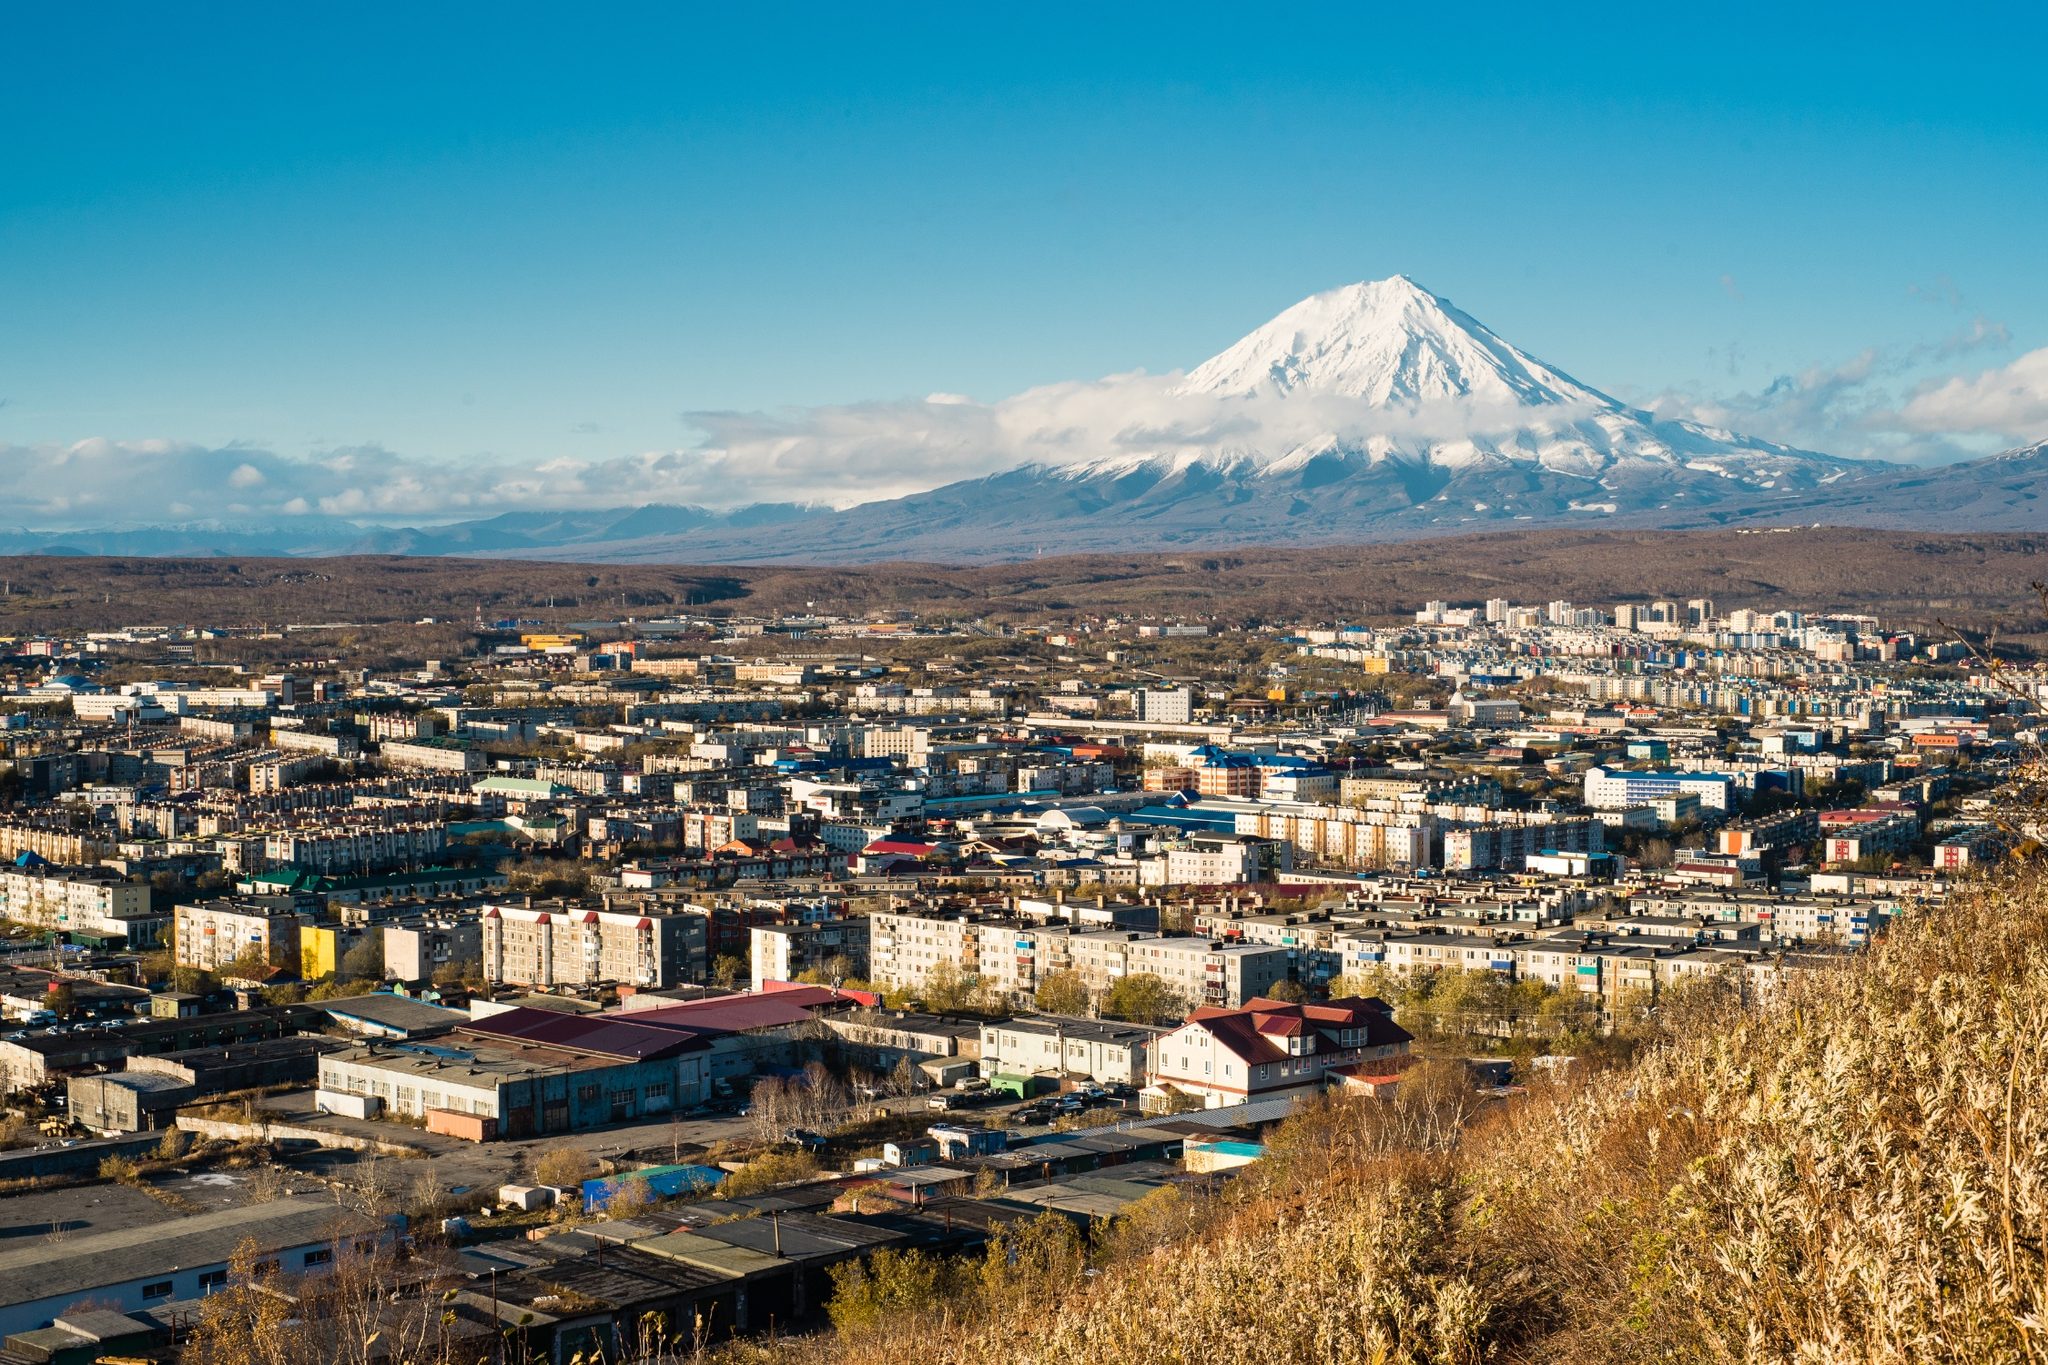What kind of businesses would thrive in this region and why? The businesses that would thrive in Petropavlovsk-Kamchatsky are those that leverage the unique natural and cultural attributes of the region. Tourism-related enterprises, including adventure tourism, eco-tourism, and cultural tours, could flourish by showcasing the breathtaking landscapes, volcanic features, and indigenous heritage. Sustainable technology firms focusing on geothermal energy would benefit from the region's volcanic activity, providing clean energy solutions locally and possibly internationally. Fisheries and seafood processing businesses could capitalize on the abundant marine resources in nearby waters, while local handicrafts and artisanal products would attract both tourists and international markets. Additionally, outdoor gear and apparel companies could thrive, catering to the needs of residents and tourists engaging in the region's diverse recreational activities, such as hiking, skiing, and mountaineering. What leisure activities could residents and tourists enjoy in this region? Residents and tourists in Petropavlovsk-Kamchatsky can enjoy a plethora of leisure activities given the region’s natural beauty and unique terrain. Hiking and trekking in the surrounding mountains and volcanic areas offer breathtaking views and an exhilarating experience. Winter sports enthusiasts can indulge in skiing and snowboarding on the slopes of the Koryaksky volcano and other nearby mountains. The nearby waters are perfect for fishing, boating, and wildlife watching, especially for spotting marine fauna such as whales and seals. Exploring the rich biodiversity through guided nature tours in the Kamchatka Peninsula’s reserves and parks is a must. Additionally, cultural tours that delve into the region's indigenous heritage and local traditions offer a fascinating insight into the history and culture of the area. For a more leisurely pace, enjoying the local cuisine at various eateries and cafes, while taking in the scenic views, provides a perfect blend of relaxation and local flavor. 